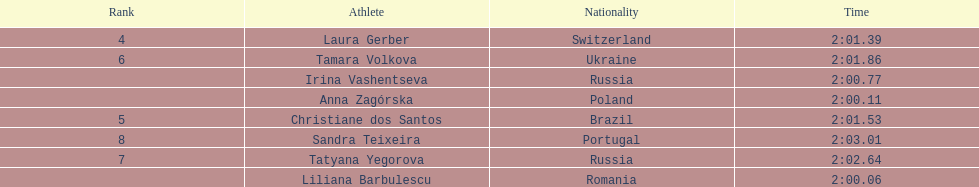What was the time difference between the first place finisher and the eighth place finisher? 2.95. 